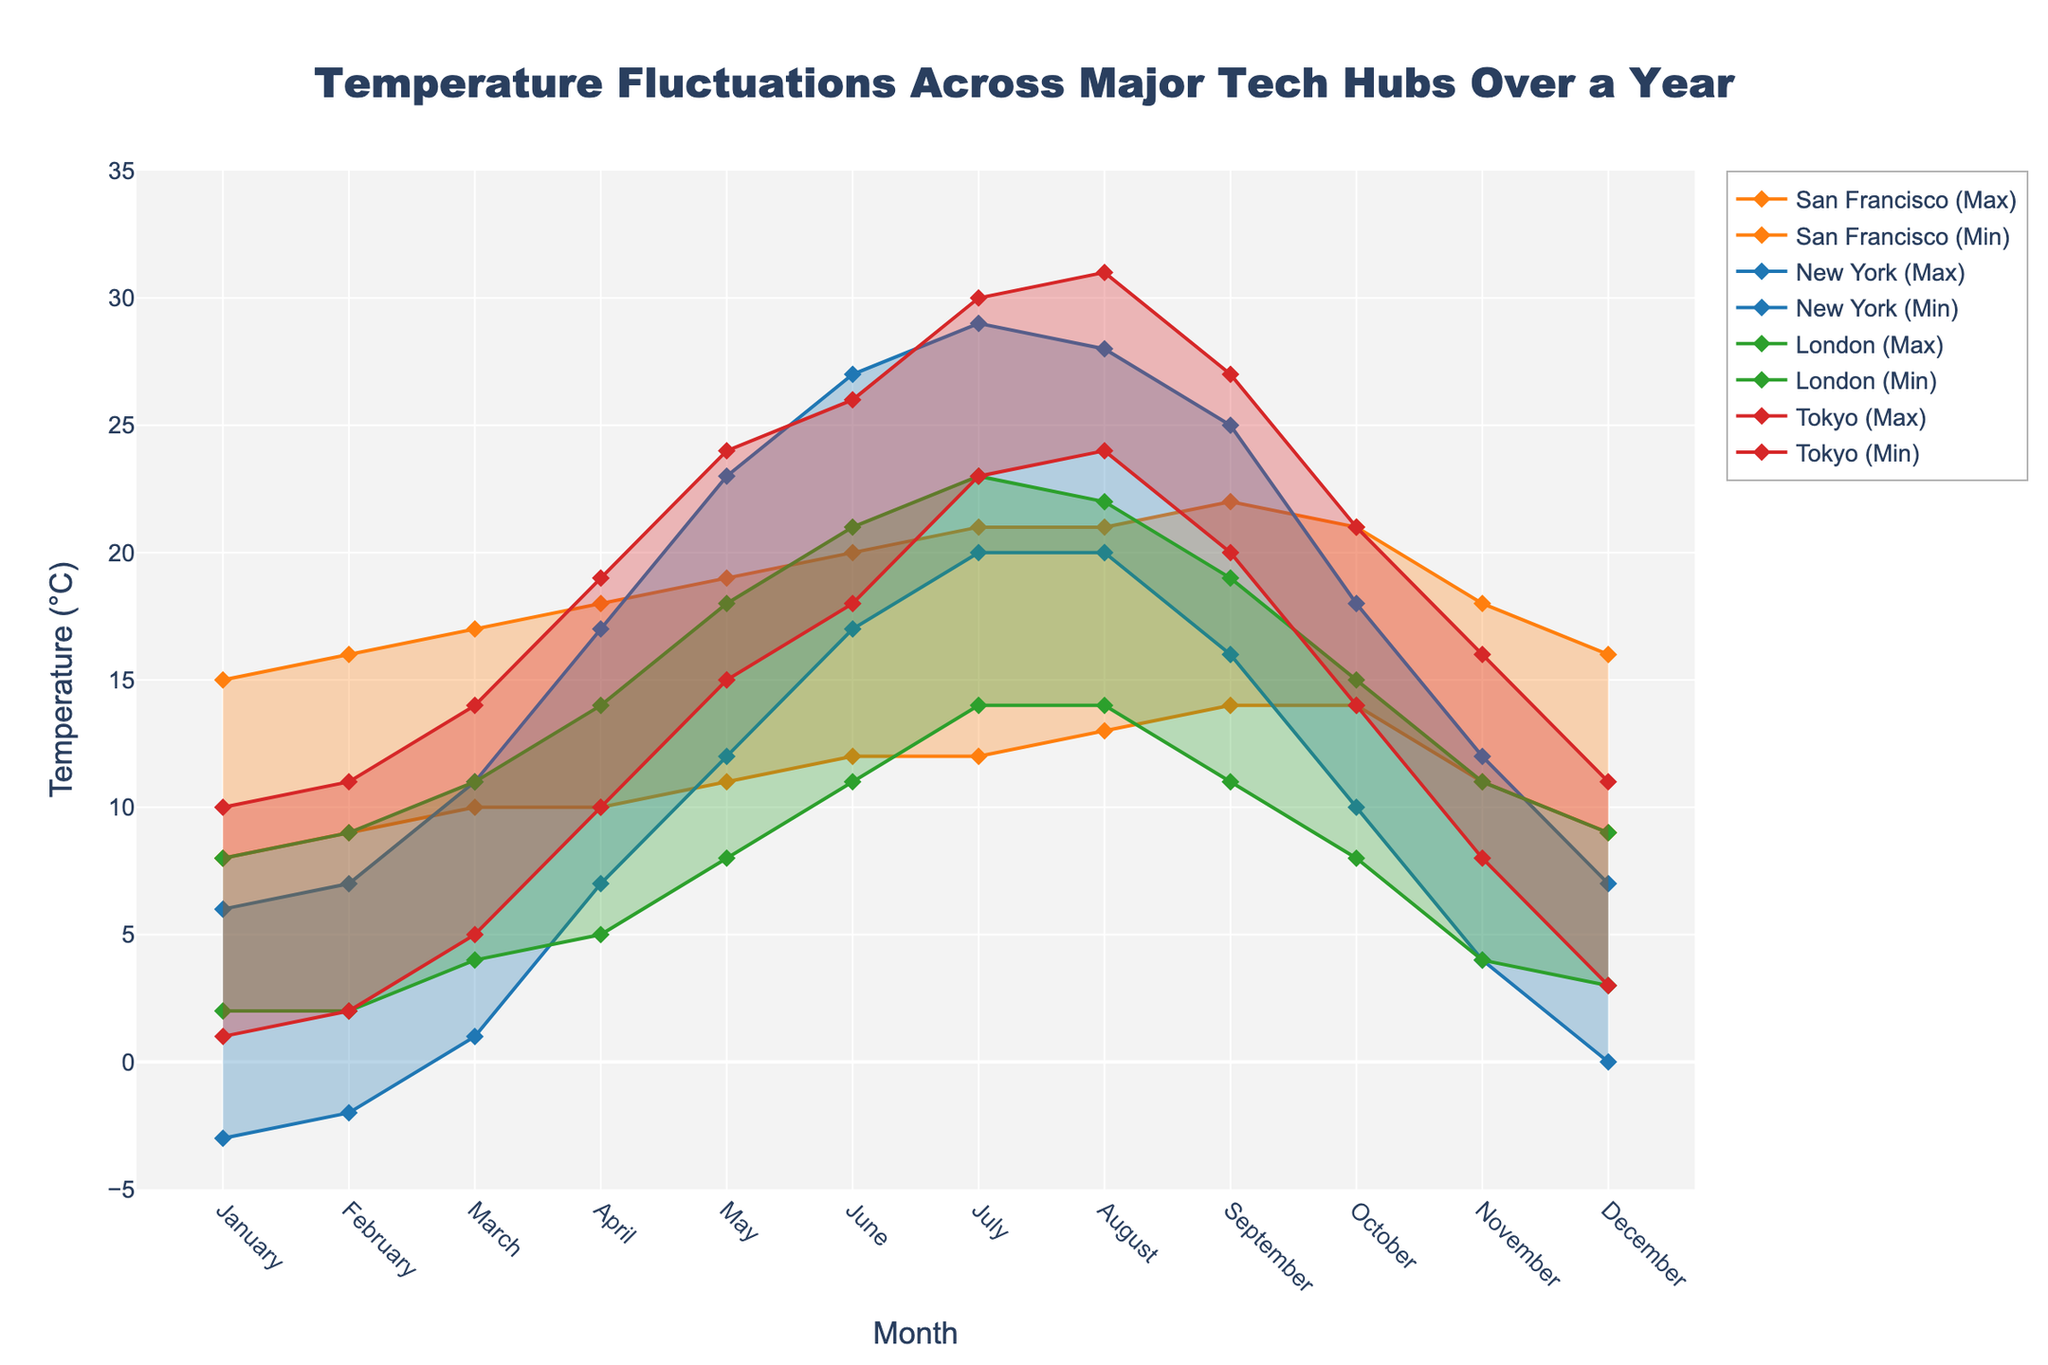What is the title of the figure? The title of the figure is displayed at the top in bold, indicating the main topic represented by the visual data.
Answer: Temperature Fluctuations Across Major Tech Hubs Over a Year How many data points are there for each city? Each city has data points for each month of the year, making it easy to count.
Answer: 12 Which city has the highest maximum temperature in July? By examining the temperature range area for each city, the maximum temperatures are marked and easily identifiable in July.
Answer: Tokyo During which month does New York have the smallest temperature range? The smallest range is found by identifying the month with the smallest difference between the maximum and minimum temperatures for New York.
Answer: March How does the temperature range in San Francisco in January compare to its range in September? Calculate the temperature range in January (15 - 8) and in September (22 - 14) for San Francisco and compare them.
Answer: The range is the same (7°C) What is the average maximum temperature in London during the summer months (June, July, August)? Identify the maximum temperatures for London in June, July, and August (21°C, 23°C, 22°C), sum them up, and divide by 3.
Answer: 22°C Which city has the overall highest minimum temperature throughout the year? Find the minimum temperature plotted for each city, then identify the highest yearly min value among them.
Answer: Tokyo Are there any months when the minimum temperature in New York is higher than the maximum temperature in London? Compare each month's minimum temperature in New York to the maximum temperature in London and identify any months where this is true.
Answer: No What is the difference between the maximum temperatures in Tokyo and San Francisco in August? Subtract the maximum temperature in San Francisco (21°C) from the maximum temperature in Tokyo (31°C) for August.
Answer: 10°C Which city has the most consistent temperature range throughout the year? Assess the visual representation of the temperature ranges for each city over the year and identify the city with the least fluctuation in the range.
Answer: San Francisco 